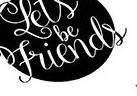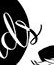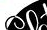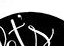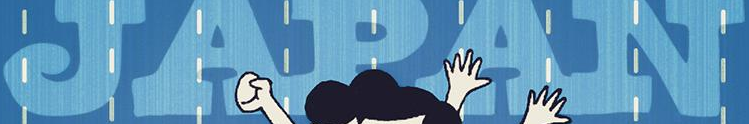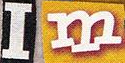Read the text from these images in sequence, separated by a semicolon. Friends; ds; ##; t's; JAPAN; Im 